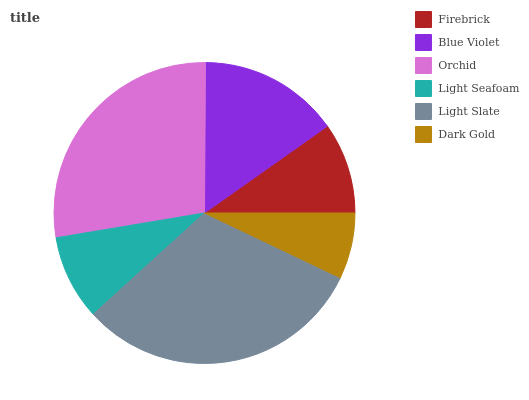Is Dark Gold the minimum?
Answer yes or no. Yes. Is Light Slate the maximum?
Answer yes or no. Yes. Is Blue Violet the minimum?
Answer yes or no. No. Is Blue Violet the maximum?
Answer yes or no. No. Is Blue Violet greater than Firebrick?
Answer yes or no. Yes. Is Firebrick less than Blue Violet?
Answer yes or no. Yes. Is Firebrick greater than Blue Violet?
Answer yes or no. No. Is Blue Violet less than Firebrick?
Answer yes or no. No. Is Blue Violet the high median?
Answer yes or no. Yes. Is Firebrick the low median?
Answer yes or no. Yes. Is Orchid the high median?
Answer yes or no. No. Is Dark Gold the low median?
Answer yes or no. No. 